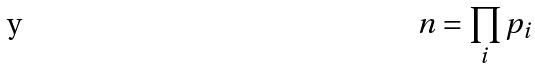<formula> <loc_0><loc_0><loc_500><loc_500>n = \prod _ { i } p _ { i }</formula> 